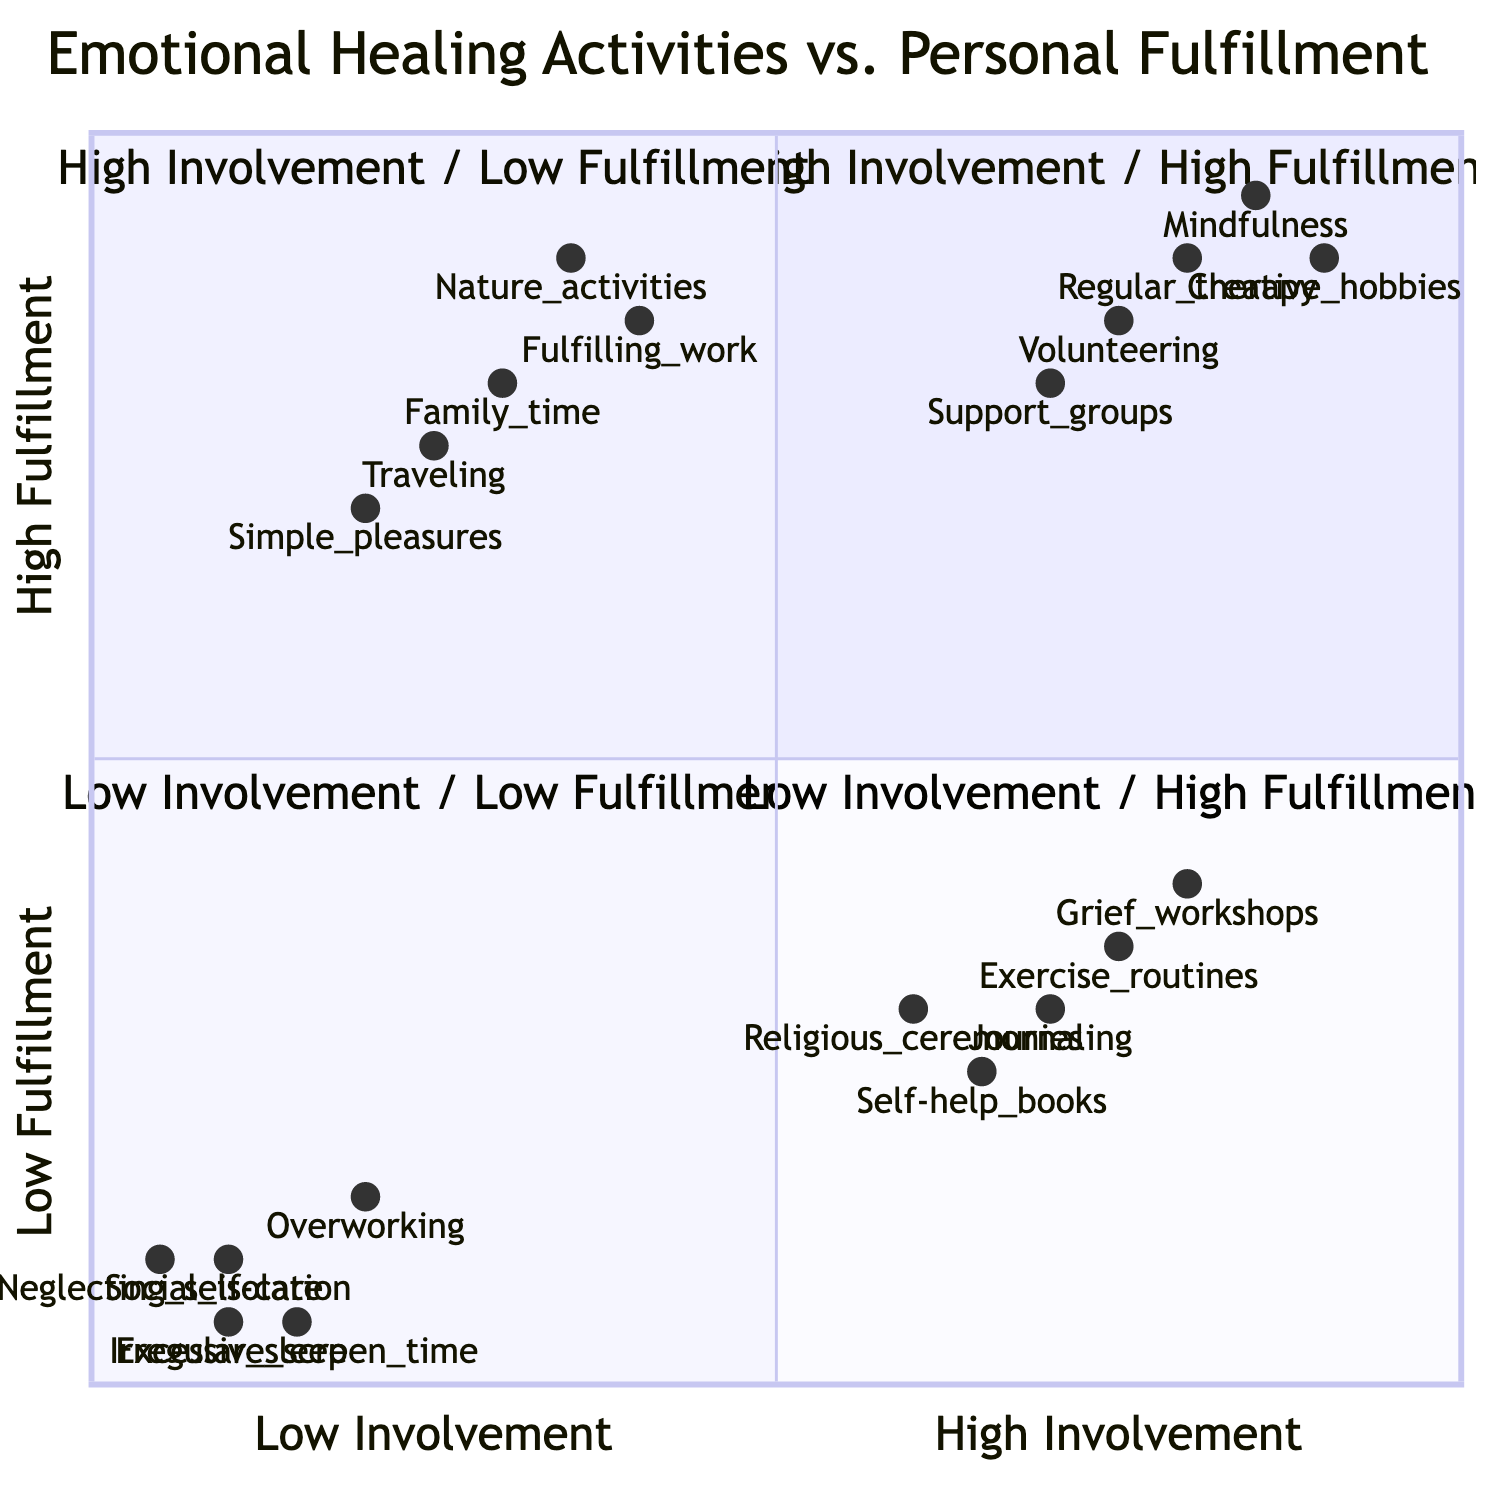What activities fall under the quadrant of high involvement in healing activities and high personal fulfillment? The quadrant labeled "High Involvement in Healing Activities / High Personal Fulfillment" lists activities that contribute positively to one's emotional well-being while also involving substantial engagement. The specific activities mentioned are Regular therapy sessions, Volunteering at local charities, Joining and actively participating in support groups, Practicing mindfulness and meditation daily, and Engaging in creative hobbies.
Answer: Regular therapy sessions, Volunteering at local charities, Joining and actively participating in support groups, Practicing mindfulness and meditation daily, Engaging in creative hobbies Which activity shows the lowest personal fulfillment in the high involvement quadrant? In the quadrant of "High Involvement in Healing Activities / Low Personal Fulfillment," we look for the activity with the lowest fulfillment value. The activities are listed, and based on their fulfillment scores, 'Self-help books on loss and healing' has the lowest fulfillment score of 0.25.
Answer: Self-help books on loss and healing What is the impact of engaging in low involvement and low fulfillment activities? The quadrant "Low Involvement in Healing Activities / Low Personal Fulfillment" leads to feelings of emptiness and unresolved grief. The statement about this quadrant specifically highlights that engaging in these activities may result in persistent negative emotional states.
Answer: Persisting feelings of emptiness and unresolved grief How many activities are labeled under high involvement and high fulfillment? The quadrant titled "High Involvement in Healing Activities / High Personal Fulfillment" contains a total of five listed activities. This means there are five distinct activities in that quadrant.
Answer: 5 What activities yield high personal fulfillment despite low involvement in healing practices? The quadrant "Low Involvement in Healing Activities / High Personal Fulfillment" showcases activities that provide personal happiness without focused healing work. The activities listed there include Spending quality time with family and friends, Engaging in fulfilling work, Exploring nature, Traveling to new places, and Indulging in simple pleasures.
Answer: Spending quality time with family and friends, Engaging in fulfilling work, Exploring nature, Traveling to new places, Indulging in simple pleasures Which quadrant has activities that involve both high engagement and low fulfillment? Looking at the quadrants, "High Involvement in Healing Activities / Low Personal Fulfillment" contains activities that require significant effort yet yield low fulfillment, indicating a struggle to find joy through these actions.
Answer: High Involvement in Healing Activities / Low Personal Fulfillment 